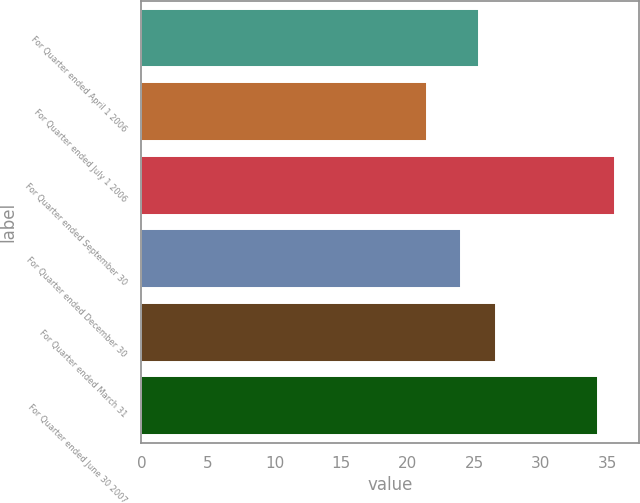Convert chart. <chart><loc_0><loc_0><loc_500><loc_500><bar_chart><fcel>For Quarter ended April 1 2006<fcel>For Quarter ended July 1 2006<fcel>For Quarter ended September 30<fcel>For Quarter ended December 30<fcel>For Quarter ended March 31<fcel>For Quarter ended June 30 2007<nl><fcel>25.32<fcel>21.42<fcel>35.56<fcel>24.02<fcel>26.62<fcel>34.26<nl></chart> 